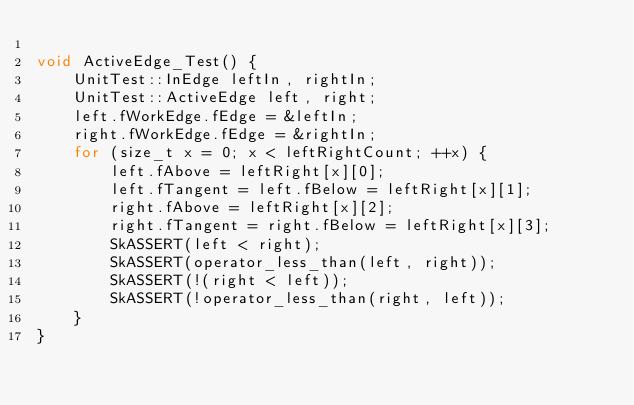<code> <loc_0><loc_0><loc_500><loc_500><_C++_>
void ActiveEdge_Test() {
    UnitTest::InEdge leftIn, rightIn;
    UnitTest::ActiveEdge left, right;
    left.fWorkEdge.fEdge = &leftIn;
    right.fWorkEdge.fEdge = &rightIn;
    for (size_t x = 0; x < leftRightCount; ++x) {
        left.fAbove = leftRight[x][0];
        left.fTangent = left.fBelow = leftRight[x][1];
        right.fAbove = leftRight[x][2];
        right.fTangent = right.fBelow = leftRight[x][3];
        SkASSERT(left < right);
        SkASSERT(operator_less_than(left, right));
        SkASSERT(!(right < left));
        SkASSERT(!operator_less_than(right, left));
    }
}
</code> 